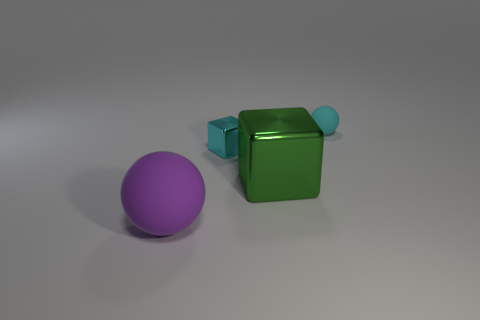Add 3 tiny cyan rubber things. How many objects exist? 7 Subtract 0 green cylinders. How many objects are left? 4 Subtract all cyan shiny objects. Subtract all big cyan metallic things. How many objects are left? 3 Add 3 big purple objects. How many big purple objects are left? 4 Add 1 big green metal objects. How many big green metal objects exist? 2 